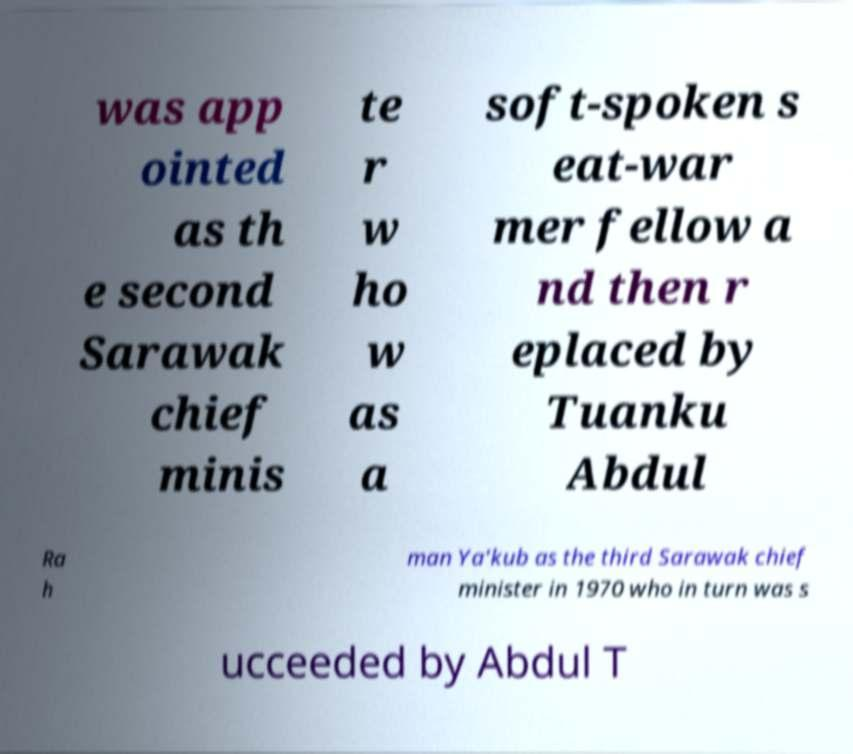Could you extract and type out the text from this image? was app ointed as th e second Sarawak chief minis te r w ho w as a soft-spoken s eat-war mer fellow a nd then r eplaced by Tuanku Abdul Ra h man Ya'kub as the third Sarawak chief minister in 1970 who in turn was s ucceeded by Abdul T 